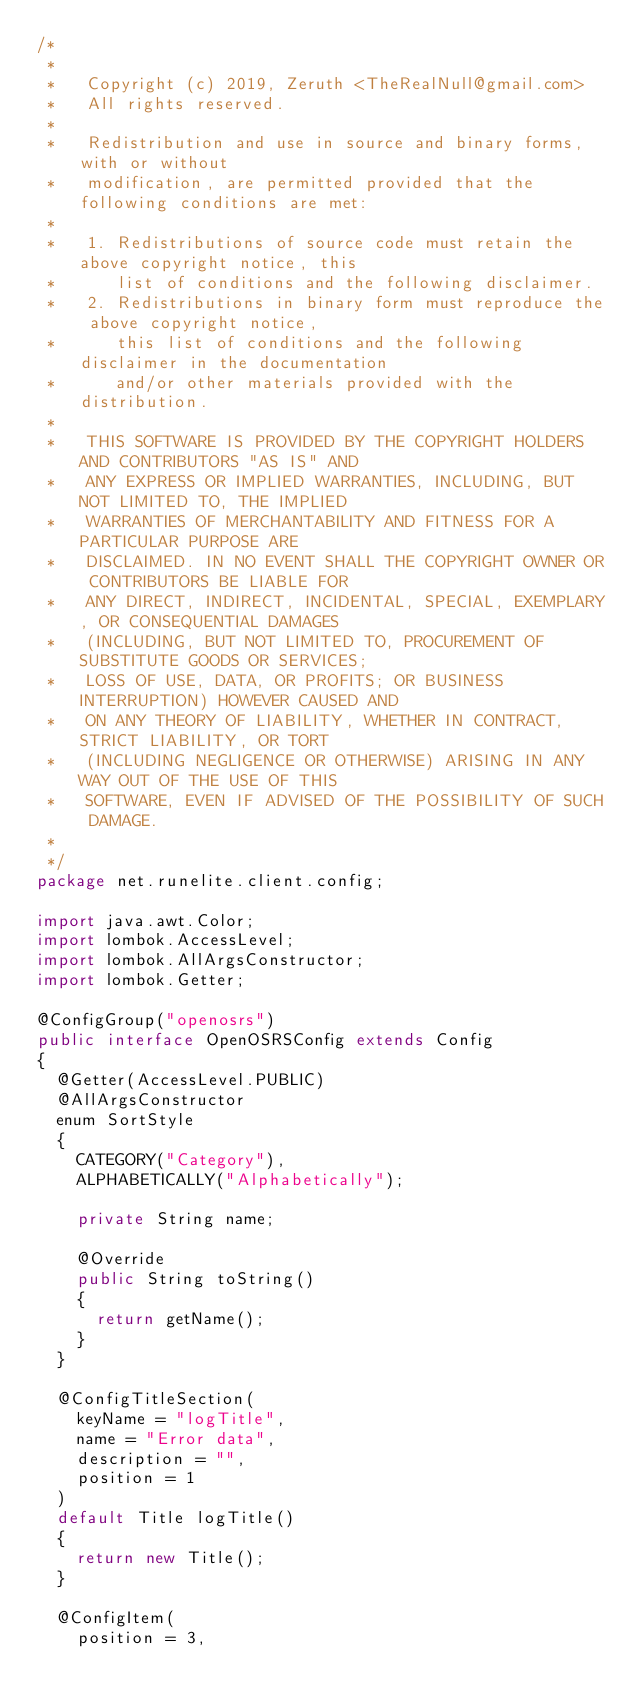<code> <loc_0><loc_0><loc_500><loc_500><_Java_>/*
 *
 *   Copyright (c) 2019, Zeruth <TheRealNull@gmail.com>
 *   All rights reserved.
 *
 *   Redistribution and use in source and binary forms, with or without
 *   modification, are permitted provided that the following conditions are met:
 *
 *   1. Redistributions of source code must retain the above copyright notice, this
 *      list of conditions and the following disclaimer.
 *   2. Redistributions in binary form must reproduce the above copyright notice,
 *      this list of conditions and the following disclaimer in the documentation
 *      and/or other materials provided with the distribution.
 *
 *   THIS SOFTWARE IS PROVIDED BY THE COPYRIGHT HOLDERS AND CONTRIBUTORS "AS IS" AND
 *   ANY EXPRESS OR IMPLIED WARRANTIES, INCLUDING, BUT NOT LIMITED TO, THE IMPLIED
 *   WARRANTIES OF MERCHANTABILITY AND FITNESS FOR A PARTICULAR PURPOSE ARE
 *   DISCLAIMED. IN NO EVENT SHALL THE COPYRIGHT OWNER OR CONTRIBUTORS BE LIABLE FOR
 *   ANY DIRECT, INDIRECT, INCIDENTAL, SPECIAL, EXEMPLARY, OR CONSEQUENTIAL DAMAGES
 *   (INCLUDING, BUT NOT LIMITED TO, PROCUREMENT OF SUBSTITUTE GOODS OR SERVICES;
 *   LOSS OF USE, DATA, OR PROFITS; OR BUSINESS INTERRUPTION) HOWEVER CAUSED AND
 *   ON ANY THEORY OF LIABILITY, WHETHER IN CONTRACT, STRICT LIABILITY, OR TORT
 *   (INCLUDING NEGLIGENCE OR OTHERWISE) ARISING IN ANY WAY OUT OF THE USE OF THIS
 *   SOFTWARE, EVEN IF ADVISED OF THE POSSIBILITY OF SUCH DAMAGE.
 *
 */
package net.runelite.client.config;

import java.awt.Color;
import lombok.AccessLevel;
import lombok.AllArgsConstructor;
import lombok.Getter;

@ConfigGroup("openosrs")
public interface OpenOSRSConfig extends Config
{
	@Getter(AccessLevel.PUBLIC)
	@AllArgsConstructor
	enum SortStyle
	{
		CATEGORY("Category"),
		ALPHABETICALLY("Alphabetically");

		private String name;

		@Override
		public String toString()
		{
			return getName();
		}
	}

	@ConfigTitleSection(
		keyName = "logTitle",
		name = "Error data",
		description = "",
		position = 1
	)
	default Title logTitle()
	{
		return new Title();
	}

	@ConfigItem(
		position = 3,</code> 